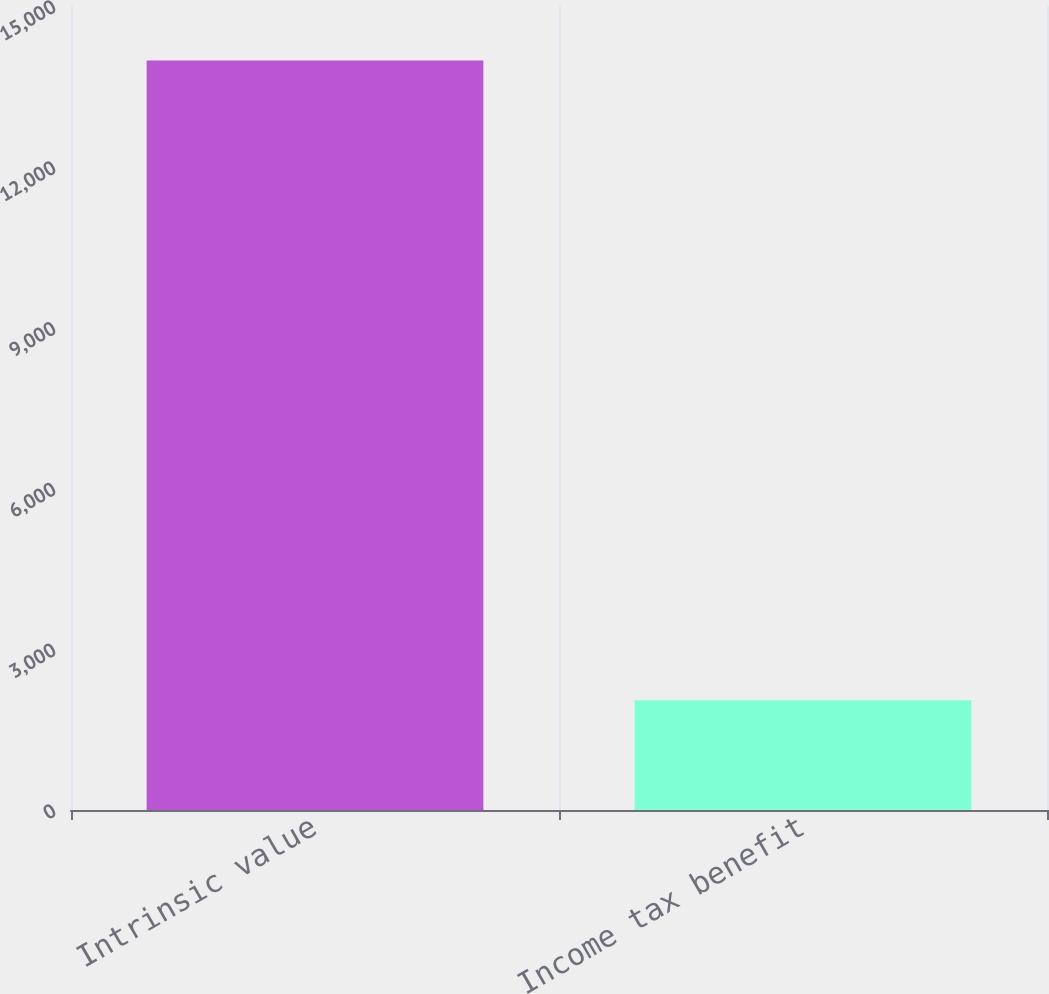Convert chart to OTSL. <chart><loc_0><loc_0><loc_500><loc_500><bar_chart><fcel>Intrinsic value<fcel>Income tax benefit<nl><fcel>13983<fcel>2049<nl></chart> 